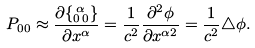<formula> <loc_0><loc_0><loc_500><loc_500>P _ { 0 0 } \approx \frac { \partial \{ ^ { \, \alpha } _ { 0 \, 0 } \} } { \partial x ^ { \alpha } } = \frac { 1 } { c ^ { 2 } } \frac { \partial ^ { 2 } \phi } { \partial x ^ { \alpha 2 } } = \frac { 1 } { c ^ { 2 } } \triangle \phi .</formula> 